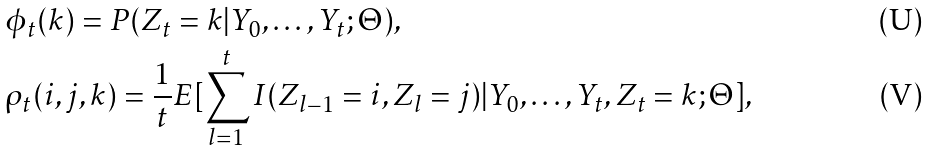Convert formula to latex. <formula><loc_0><loc_0><loc_500><loc_500>& \phi _ { t } ( k ) = P ( Z _ { t } = k | Y _ { 0 } , \dots , Y _ { t } ; \Theta ) , \\ & \rho _ { t } ( i , j , k ) = \frac { 1 } { t } E [ \sum ^ { t } _ { l = 1 } I ( Z _ { l - 1 } = i , Z _ { l } = j ) | Y _ { 0 } , \dots , Y _ { t } , Z _ { t } = k ; \Theta ] ,</formula> 